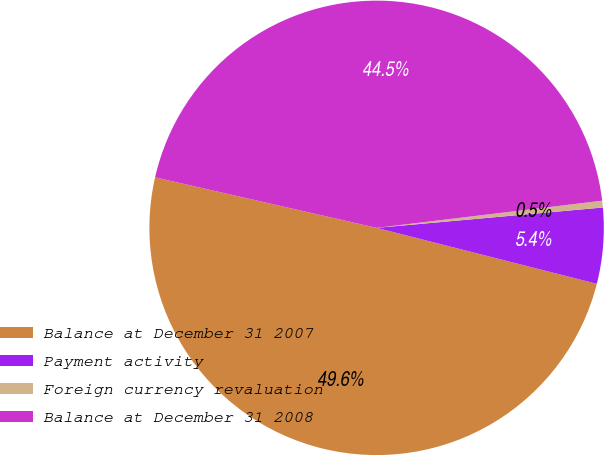Convert chart. <chart><loc_0><loc_0><loc_500><loc_500><pie_chart><fcel>Balance at December 31 2007<fcel>Payment activity<fcel>Foreign currency revaluation<fcel>Balance at December 31 2008<nl><fcel>49.61%<fcel>5.39%<fcel>0.48%<fcel>44.53%<nl></chart> 